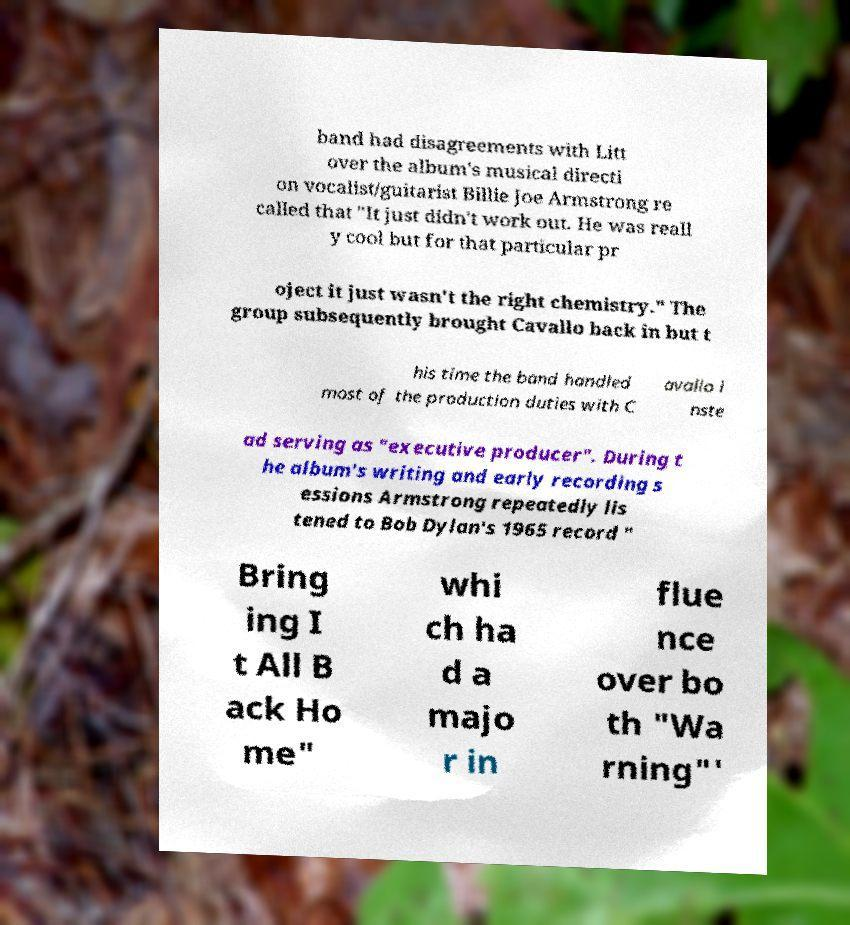Could you extract and type out the text from this image? band had disagreements with Litt over the album's musical directi on vocalist/guitarist Billie Joe Armstrong re called that "It just didn't work out. He was reall y cool but for that particular pr oject it just wasn't the right chemistry." The group subsequently brought Cavallo back in but t his time the band handled most of the production duties with C avallo i nste ad serving as "executive producer". During t he album's writing and early recording s essions Armstrong repeatedly lis tened to Bob Dylan's 1965 record " Bring ing I t All B ack Ho me" whi ch ha d a majo r in flue nce over bo th "Wa rning"' 